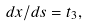<formula> <loc_0><loc_0><loc_500><loc_500>d { x } / d s = { t } _ { 3 } ,</formula> 